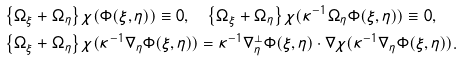Convert formula to latex. <formula><loc_0><loc_0><loc_500><loc_500>& \left \{ \Omega _ { \xi } + \Omega _ { \eta } \right \} \chi ( \Phi ( \xi , \eta ) ) \equiv 0 , \quad \left \{ \Omega _ { \xi } + \Omega _ { \eta } \right \} \chi ( \kappa ^ { - 1 } \Omega _ { \eta } \Phi ( \xi , \eta ) ) \equiv 0 , \\ & \left \{ \Omega _ { \xi } + \Omega _ { \eta } \right \} \chi ( \kappa ^ { - 1 } \nabla _ { \eta } \Phi ( \xi , \eta ) ) = \kappa ^ { - 1 } \nabla ^ { \perp } _ { \eta } \Phi ( \xi , \eta ) \cdot \nabla \chi ( \kappa ^ { - 1 } \nabla _ { \eta } \Phi ( \xi , \eta ) ) .</formula> 